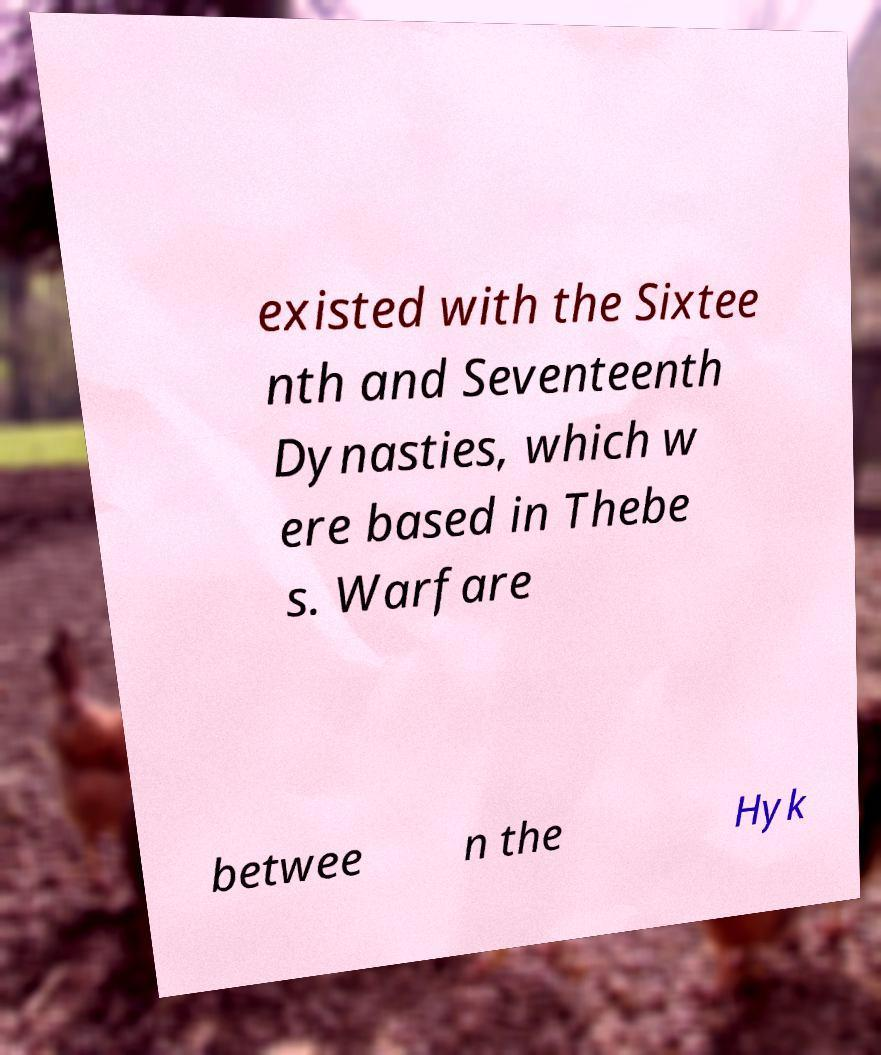I need the written content from this picture converted into text. Can you do that? existed with the Sixtee nth and Seventeenth Dynasties, which w ere based in Thebe s. Warfare betwee n the Hyk 